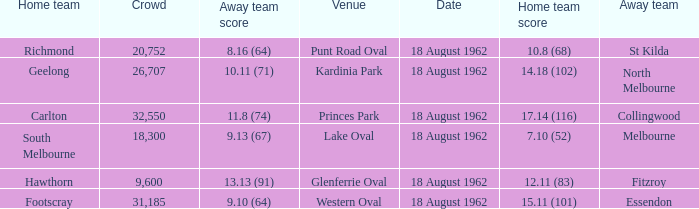At what venue where the home team scored 12.11 (83) was the crowd larger than 31,185? None. 